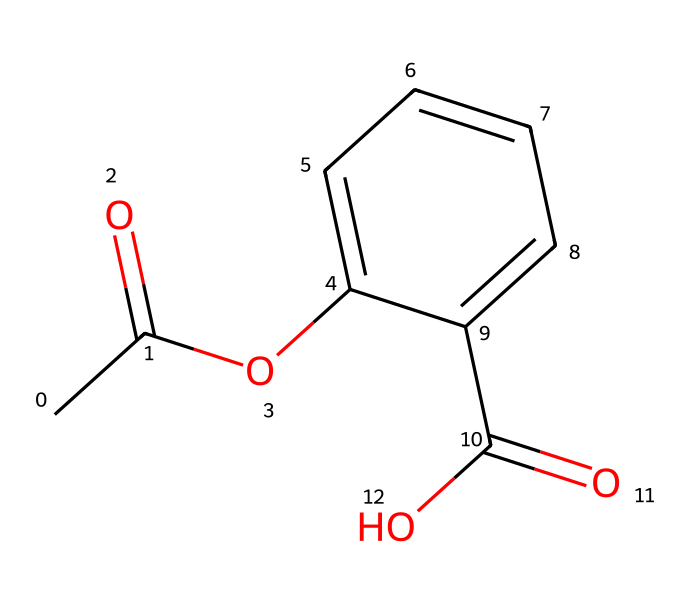What is the molecular formula of this compound? To find the molecular formula, we count the number of each type of atom in the structure represented by the SMILES. The SMILES indicates carbon (C), hydrogen (H), and oxygen (O) atoms. There are 10 carbons (C), 10 hydrogens (H), and 4 oxygens (O), giving a molecular formula of C10H10O4.
Answer: C10H10O4 How many rings are present in this chemical structure? By analyzing the chemical structure and focusing on the rings, we can see that there is one ring present in the aromatic portion of the compound. Aromatic compounds typically contain one or more cyclic structures as part of their framework.
Answer: 1 Is this compound likely to be polar or nonpolar? The presence of multiple oxygen atoms in specific functional groups (like ester and carboxylic acid) suggests the compound has polar characteristics due to the electronegative oxygen. Compounds with polar functional groups typically interact well with water and are considered polar.
Answer: polar What is the main functional group in this compound? The chemical structure reveals that the compound has both an ester (due to the -O- group adjacent to a carbonyl) and a carboxylic acid (indicated by the -C(=O)O group). However, the dominant functional group influencing its characteristics is typically considered to be the ester group due to its presence in the longest chain.
Answer: ester How many double bonds are present in the molecule? To determine the number of double bonds, we examine the structural formula identified from the SMILES. The structure displays two carbonyl groups (C=O) and one double bond in the aromatic ring, totaling three double bonds.
Answer: 3 What type of aromatic compound is this, based on its functional groups? Based on the functional groups present, the compound can be classified as a benzenoid compound since it contains a benzene ring and substituents, including an ester and carboxylic acid, making it aromatic.
Answer: benzenoid Does this synthetic fragrance include any acidic components? The presence of a carboxylic acid group (-C(=O)O) indicates that this compound includes acidic properties, as carboxylic acids are known for their acidic nature when they donate protons in solution.
Answer: yes 